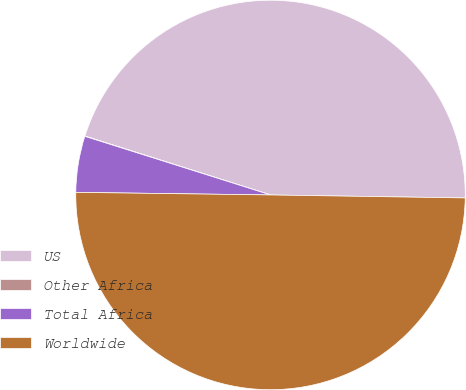Convert chart to OTSL. <chart><loc_0><loc_0><loc_500><loc_500><pie_chart><fcel>US<fcel>Other Africa<fcel>Total Africa<fcel>Worldwide<nl><fcel>45.35%<fcel>0.03%<fcel>4.65%<fcel>49.97%<nl></chart> 